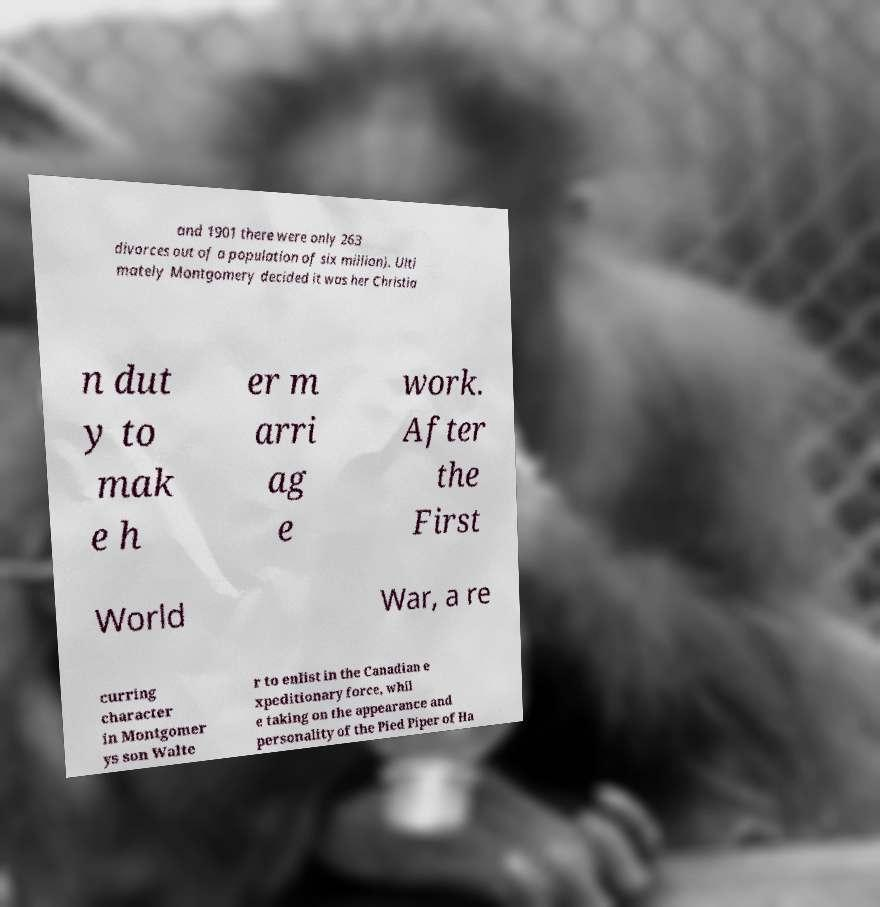Please read and relay the text visible in this image. What does it say? and 1901 there were only 263 divorces out of a population of six million). Ulti mately Montgomery decided it was her Christia n dut y to mak e h er m arri ag e work. After the First World War, a re curring character in Montgomer ys son Walte r to enlist in the Canadian e xpeditionary force, whil e taking on the appearance and personality of the Pied Piper of Ha 